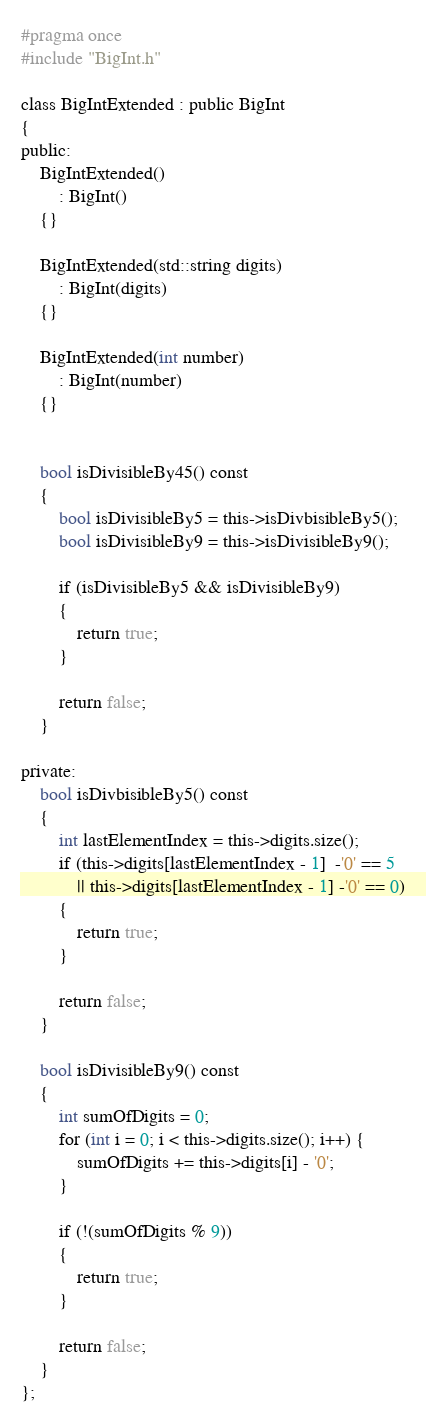<code> <loc_0><loc_0><loc_500><loc_500><_C_>#pragma once
#include "BigInt.h"

class BigIntExtended : public BigInt
{
public:
	BigIntExtended()
		: BigInt()
	{}

	BigIntExtended(std::string digits)
		: BigInt(digits)
	{}

	BigIntExtended(int number)
		: BigInt(number)
	{}


	bool isDivisibleBy45() const
	{
		bool isDivisibleBy5 = this->isDivbisibleBy5();
		bool isDivisibleBy9 = this->isDivisibleBy9();

		if (isDivisibleBy5 && isDivisibleBy9)
		{
			return true;
		}

		return false;
	}

private:
	bool isDivbisibleBy5() const
	{
		int lastElementIndex = this->digits.size();
		if (this->digits[lastElementIndex - 1]  -'0' == 5 
			|| this->digits[lastElementIndex - 1] -'0' == 0)
		{
			return true;
		}

		return false;
	}

	bool isDivisibleBy9() const
	{
		int sumOfDigits = 0;
		for (int i = 0; i < this->digits.size(); i++) {
			sumOfDigits += this->digits[i] - '0';
		}

		if (!(sumOfDigits % 9))
		{
			return true;
		}

		return false;
	}
};
</code> 